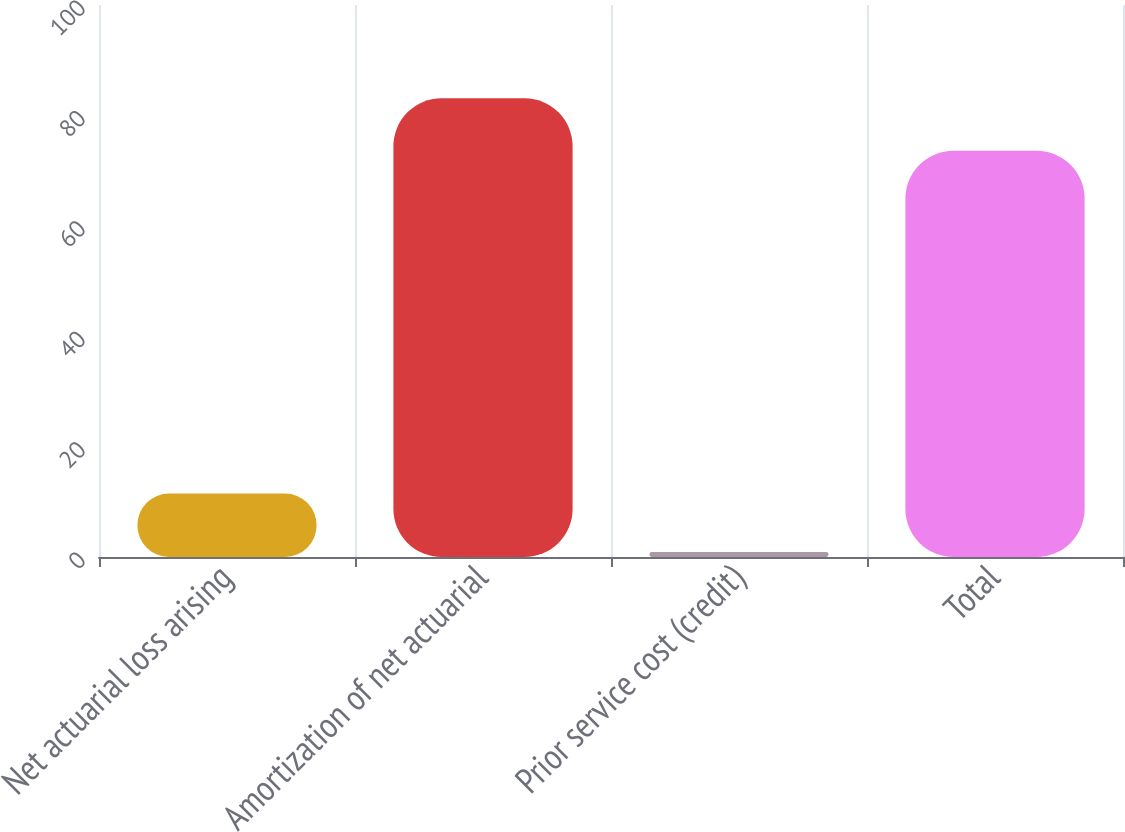Convert chart to OTSL. <chart><loc_0><loc_0><loc_500><loc_500><bar_chart><fcel>Net actuarial loss arising<fcel>Amortization of net actuarial<fcel>Prior service cost (credit)<fcel>Total<nl><fcel>11.5<fcel>83.1<fcel>0.9<fcel>73.6<nl></chart> 